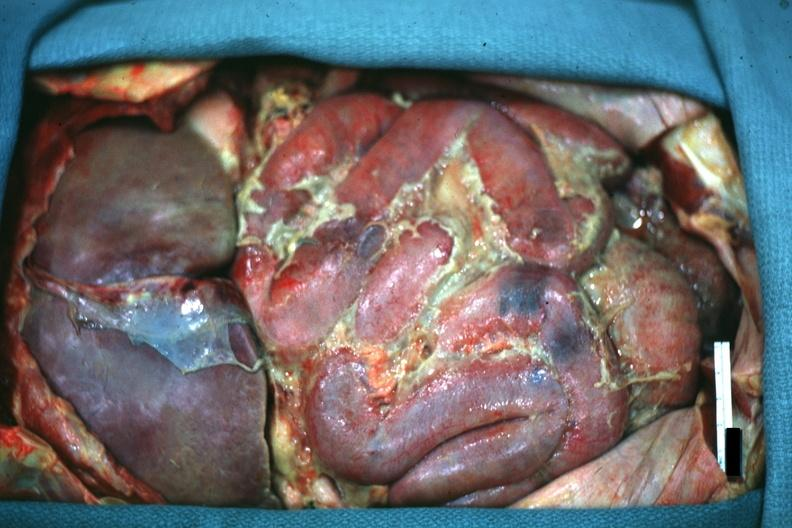does this image show opened abdomen in situ excellent example inflamed gut and yellow-green pus?
Answer the question using a single word or phrase. Yes 